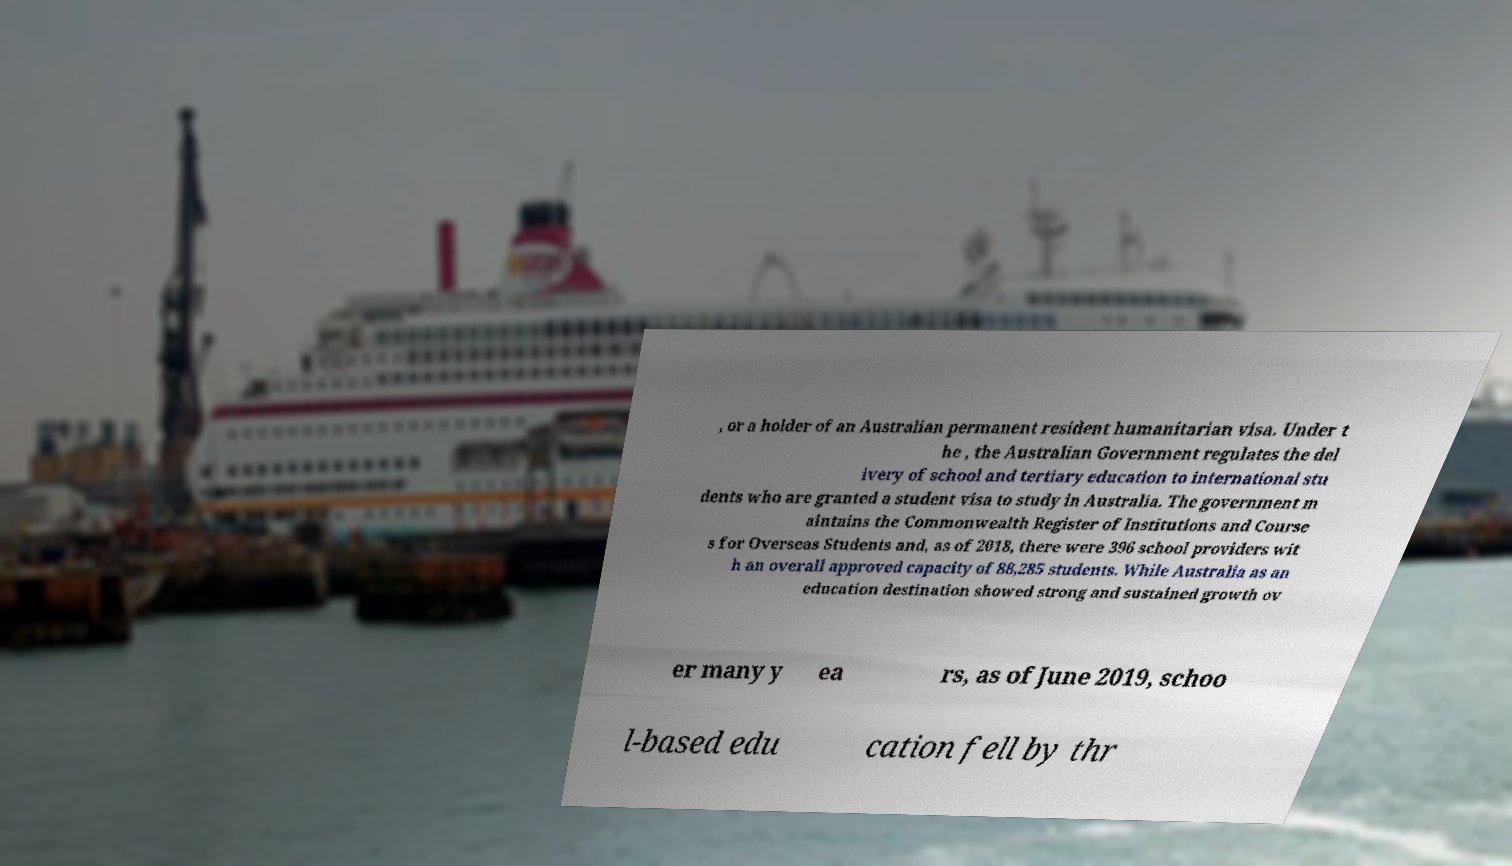Can you read and provide the text displayed in the image?This photo seems to have some interesting text. Can you extract and type it out for me? , or a holder of an Australian permanent resident humanitarian visa. Under t he , the Australian Government regulates the del ivery of school and tertiary education to international stu dents who are granted a student visa to study in Australia. The government m aintains the Commonwealth Register of Institutions and Course s for Overseas Students and, as of 2018, there were 396 school providers wit h an overall approved capacity of 88,285 students. While Australia as an education destination showed strong and sustained growth ov er many y ea rs, as of June 2019, schoo l-based edu cation fell by thr 